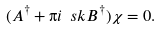<formula> <loc_0><loc_0><loc_500><loc_500>( A ^ { \dagger } + \i i \ s k B ^ { \dagger } ) \chi = 0 .</formula> 